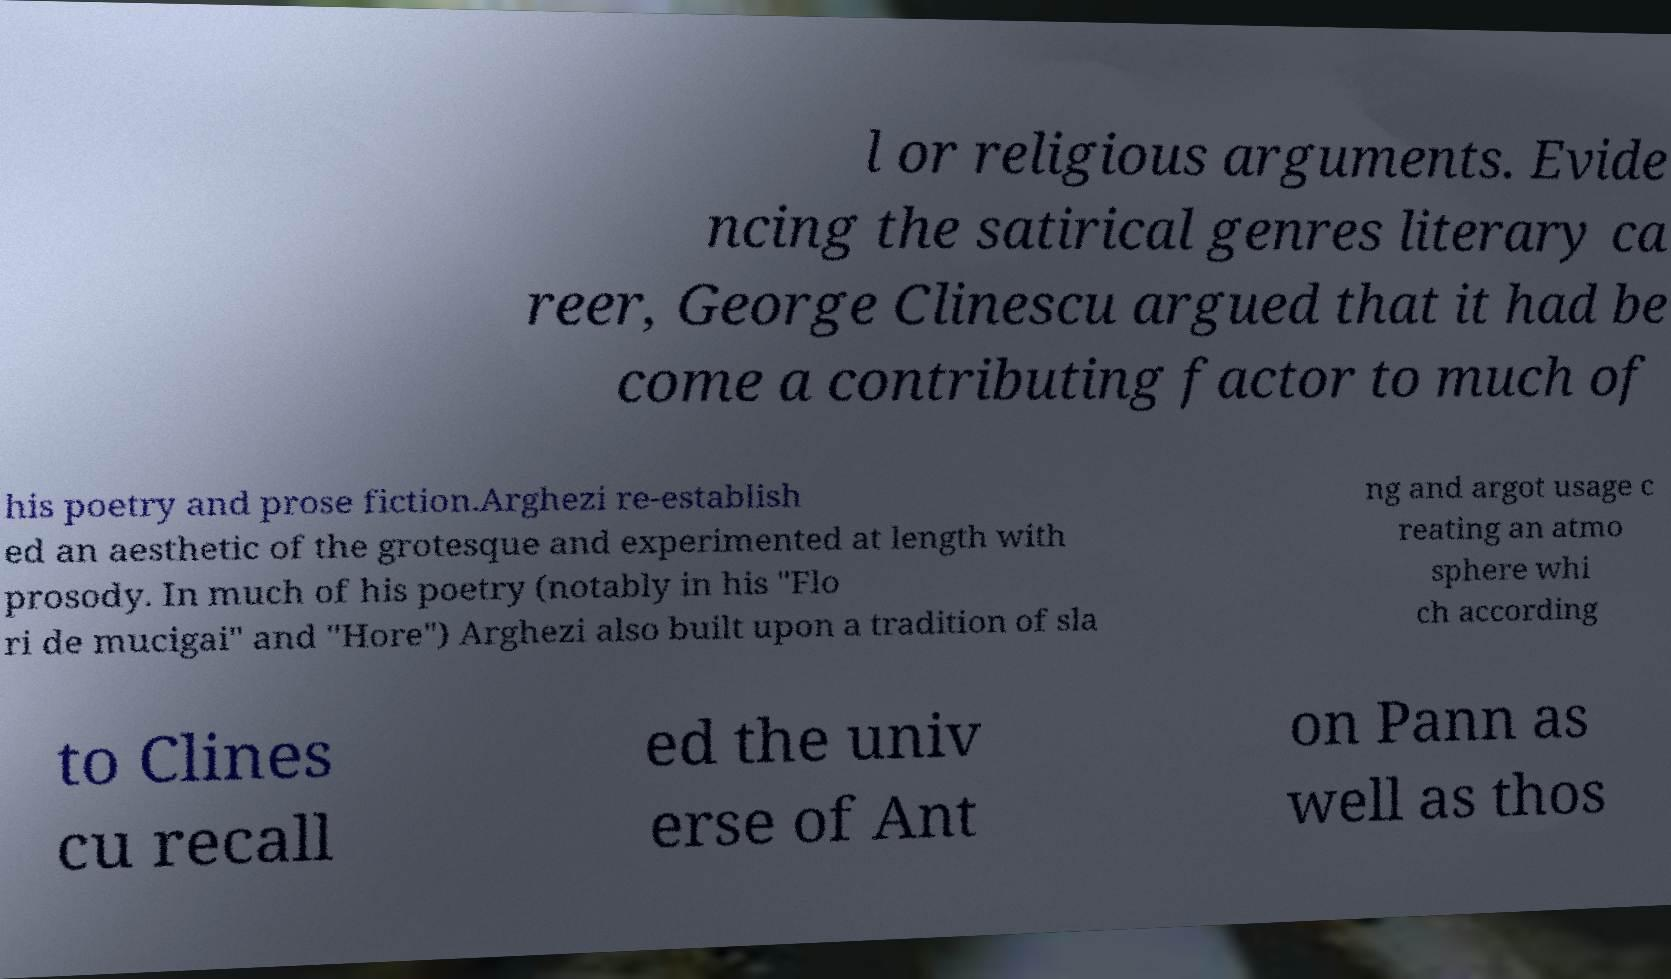Can you read and provide the text displayed in the image?This photo seems to have some interesting text. Can you extract and type it out for me? l or religious arguments. Evide ncing the satirical genres literary ca reer, George Clinescu argued that it had be come a contributing factor to much of his poetry and prose fiction.Arghezi re-establish ed an aesthetic of the grotesque and experimented at length with prosody. In much of his poetry (notably in his "Flo ri de mucigai" and "Hore") Arghezi also built upon a tradition of sla ng and argot usage c reating an atmo sphere whi ch according to Clines cu recall ed the univ erse of Ant on Pann as well as thos 